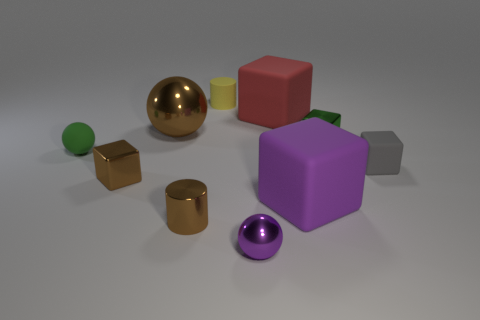Subtract all brown metal cubes. How many cubes are left? 4 Subtract all green blocks. How many blocks are left? 4 Subtract all yellow blocks. Subtract all red spheres. How many blocks are left? 5 Subtract all cylinders. How many objects are left? 8 Add 10 big yellow cylinders. How many big yellow cylinders exist? 10 Subtract 1 red cubes. How many objects are left? 9 Subtract all large cylinders. Subtract all tiny green cubes. How many objects are left? 9 Add 4 brown balls. How many brown balls are left? 5 